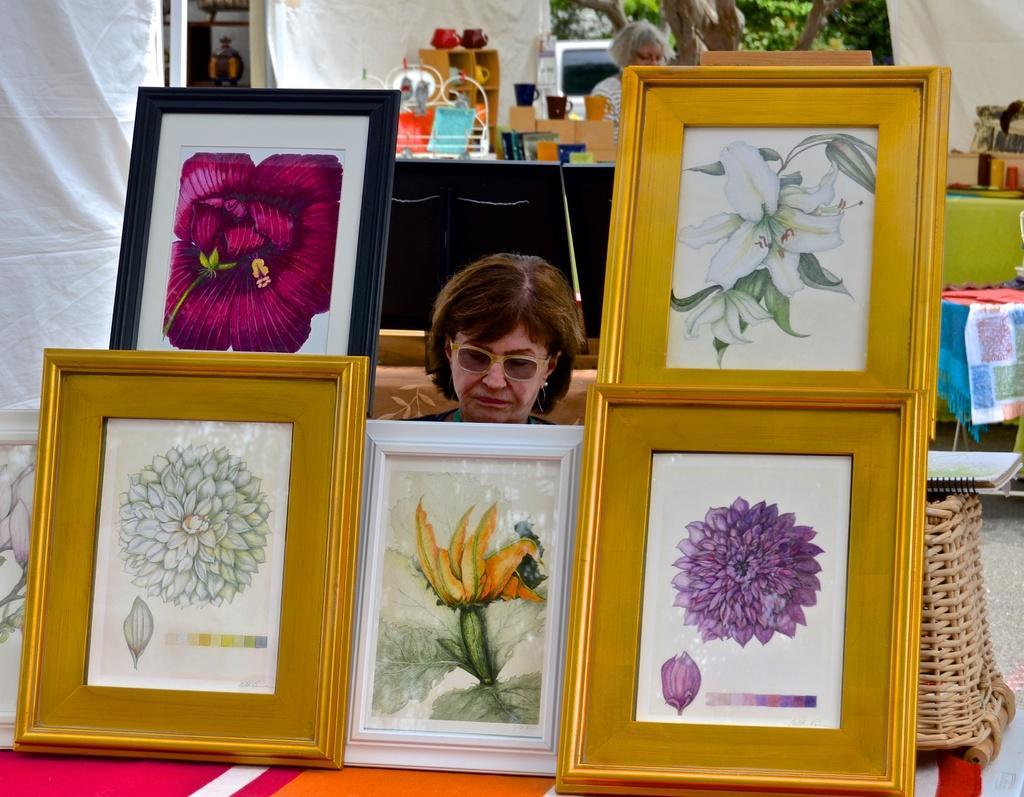Could you give a brief overview of what you see in this image? In this image in the front there are frames. In the center there is a woman and in the background there are curtains which are white in colour and there are objects, there are trees and there is a car. 